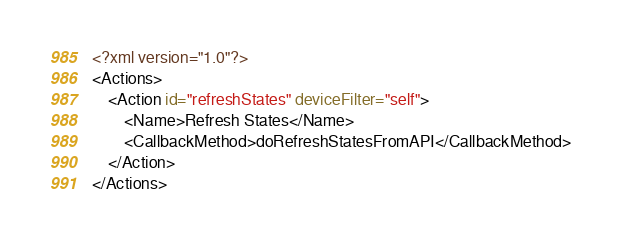Convert code to text. <code><loc_0><loc_0><loc_500><loc_500><_XML_><?xml version="1.0"?>
<Actions>
	<Action id="refreshStates" deviceFilter="self">
		<Name>Refresh States</Name>
		<CallbackMethod>doRefreshStatesFromAPI</CallbackMethod>
	</Action>
</Actions>
</code> 